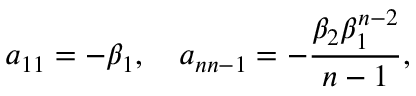<formula> <loc_0><loc_0><loc_500><loc_500>a _ { 1 1 } = - \beta _ { 1 } , \quad a _ { n n - 1 } = - \frac { \beta _ { 2 } \beta _ { 1 } ^ { n - 2 } } { n - 1 } ,</formula> 